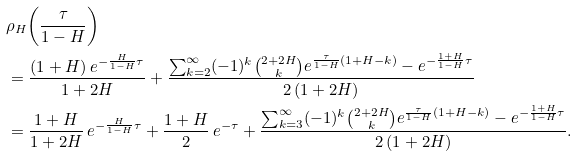<formula> <loc_0><loc_0><loc_500><loc_500>& \rho _ { H } { \left ( \frac { \tau } { 1 - H } \right ) } \\ & = \frac { ( 1 + H ) \, e ^ { - \frac { H } { 1 - H } \tau } } { 1 + 2 H } + \frac { \sum _ { k = 2 } ^ { \infty } ( - 1 ) ^ { k } \binom { 2 + 2 H } { k } e ^ { \frac { \tau } { 1 - H } ( 1 + H - k ) } - e ^ { - \frac { 1 + H } { 1 - H } \tau } } { 2 \, ( 1 + 2 H ) } \\ & = \frac { 1 + H } { 1 + 2 H } \, e ^ { - \frac { H } { 1 - H } \tau } + \frac { 1 + H } { 2 } \, e ^ { - \tau } + \frac { \sum _ { k = 3 } ^ { \infty } ( - 1 ) ^ { k } \binom { 2 + 2 H } { k } e ^ { \frac { \tau } { 1 - H } ( 1 + H - k ) } - e ^ { - \frac { 1 + H } { 1 - H } \tau } } { 2 \, ( 1 + 2 H ) } .</formula> 